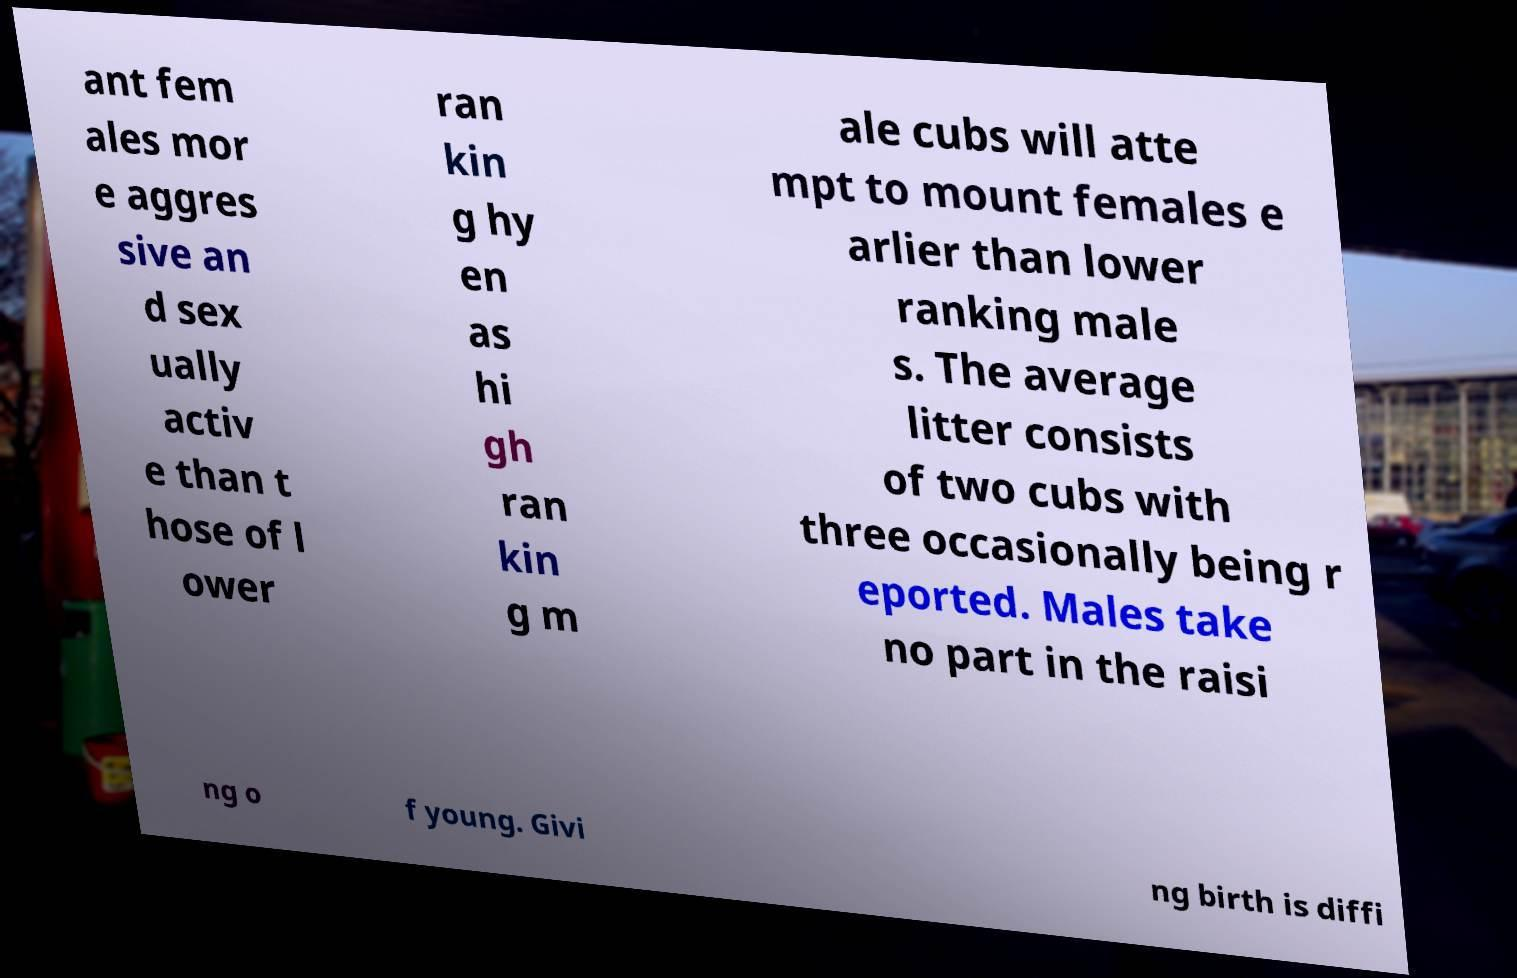Please read and relay the text visible in this image. What does it say? ant fem ales mor e aggres sive an d sex ually activ e than t hose of l ower ran kin g hy en as hi gh ran kin g m ale cubs will atte mpt to mount females e arlier than lower ranking male s. The average litter consists of two cubs with three occasionally being r eported. Males take no part in the raisi ng o f young. Givi ng birth is diffi 